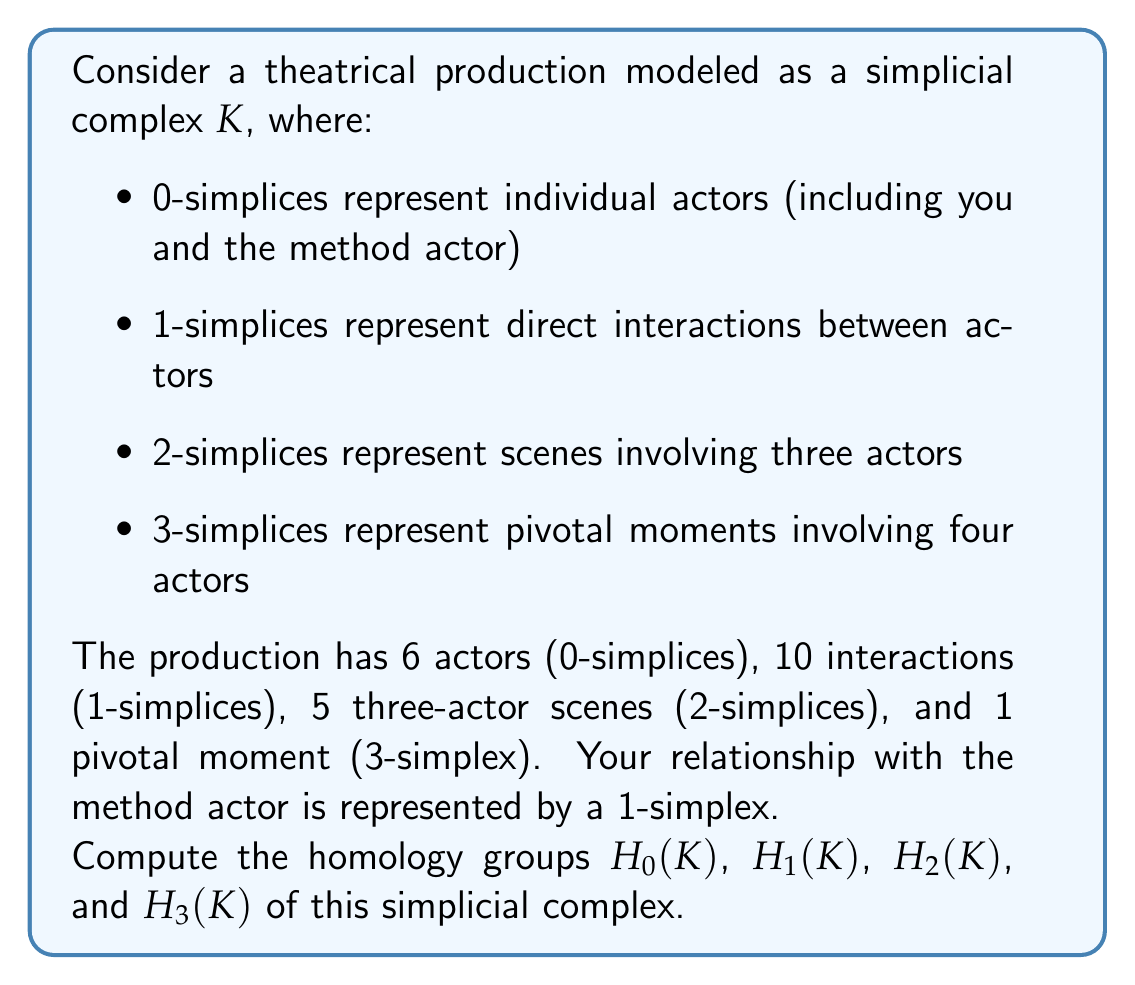Show me your answer to this math problem. To compute the homology groups, we need to follow these steps:

1. Determine the chain complex and boundary operators.
2. Calculate the kernels and images of the boundary operators.
3. Compute the homology groups as quotients of kernels and images.

Let's start with the chain complex:

$C_3 \xrightarrow{\partial_3} C_2 \xrightarrow{\partial_2} C_1 \xrightarrow{\partial_1} C_0 \xrightarrow{\partial_0} 0$

Where:
$C_3 \cong \mathbb{Z}$ (1 3-simplex)
$C_2 \cong \mathbb{Z}^5$ (5 2-simplices)
$C_1 \cong \mathbb{Z}^{10}$ (10 1-simplices)
$C_0 \cong \mathbb{Z}^6$ (6 0-simplices)

Now, let's analyze each homology group:

1. $H_0(K)$:
$\ker(\partial_0) = C_0 \cong \mathbb{Z}^6$
$\text{im}(\partial_1)$ has rank 5 (connected complex)
$H_0(K) = \ker(\partial_0) / \text{im}(\partial_1) \cong \mathbb{Z}$

2. $H_1(K)$:
$\ker(\partial_1)$ has rank $10 - 5 = 5$ (by rank-nullity theorem)
$\text{im}(\partial_2)$ has rank at most 5 (5 2-simplices)
$H_1(K) = \ker(\partial_1) / \text{im}(\partial_2)$ is either trivial or $\mathbb{Z}$

3. $H_2(K)$:
$\ker(\partial_2)$ has rank $5 - 4 = 1$ (assuming $\text{im}(\partial_2)$ has full rank)
$\text{im}(\partial_3)$ has rank 1 (1 3-simplex)
$H_2(K) = \ker(\partial_2) / \text{im}(\partial_3)$ is trivial

4. $H_3(K)$:
$\ker(\partial_3) = 0$ (no 4-simplices)
$H_3(K) = \ker(\partial_3) / \text{im}(\partial_4) = 0$

The 1-simplex representing your relationship with the method actor doesn't affect the overall homology groups but contributes to the structure of $H_1(K)$.
Answer: $H_0(K) \cong \mathbb{Z}$
$H_1(K) \cong \mathbb{Z}$ or $0$
$H_2(K) \cong 0$
$H_3(K) \cong 0$ 